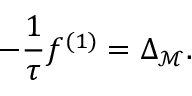Convert formula to latex. <formula><loc_0><loc_0><loc_500><loc_500>- \frac { 1 } { \tau } f ^ { ( 1 ) } = \Delta _ { \mathcal { M } } .</formula> 